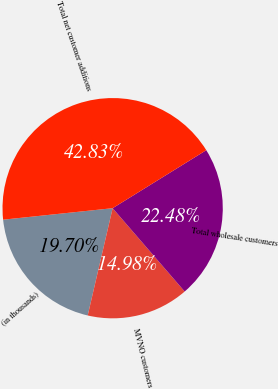<chart> <loc_0><loc_0><loc_500><loc_500><pie_chart><fcel>(in thousands)<fcel>MVNO customers<fcel>Total wholesale customers<fcel>Total net customer additions<nl><fcel>19.7%<fcel>14.98%<fcel>22.48%<fcel>42.83%<nl></chart> 